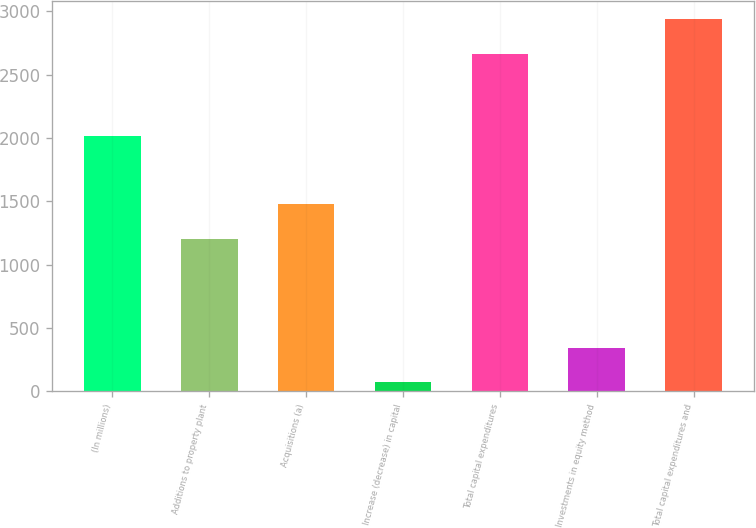<chart> <loc_0><loc_0><loc_500><loc_500><bar_chart><fcel>(In millions)<fcel>Additions to property plant<fcel>Acquisitions (a)<fcel>Increase (decrease) in capital<fcel>Total capital expenditures<fcel>Investments in equity method<fcel>Total capital expenditures and<nl><fcel>2013<fcel>1206<fcel>1477.6<fcel>73<fcel>2665<fcel>344.6<fcel>2936.6<nl></chart> 